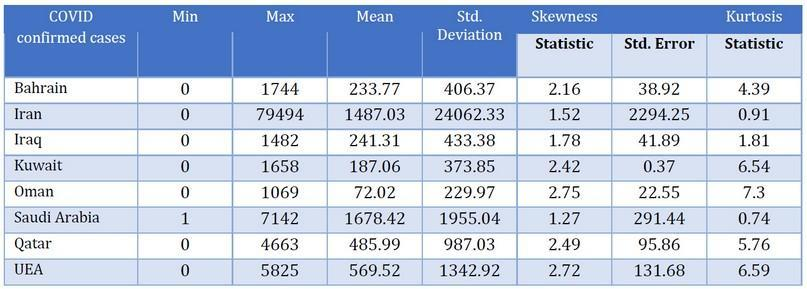WHich country has a minimum number of 1
Answer the question with a short phrase. Saudi Arabia Which country has the second highest cases Saudi Arabia Which country has the second highest Kurtosis statistic number Kuwait 